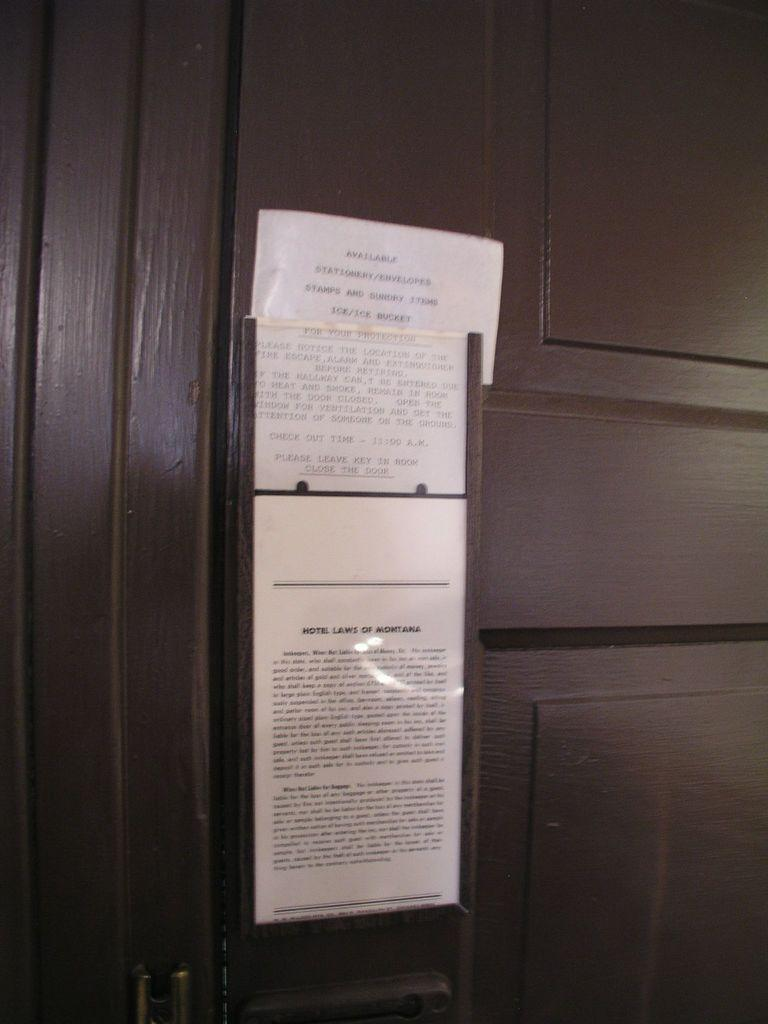<image>
Write a terse but informative summary of the picture. A Montana hotel door displaying legal notices and instructions for use of the room it leads to. 